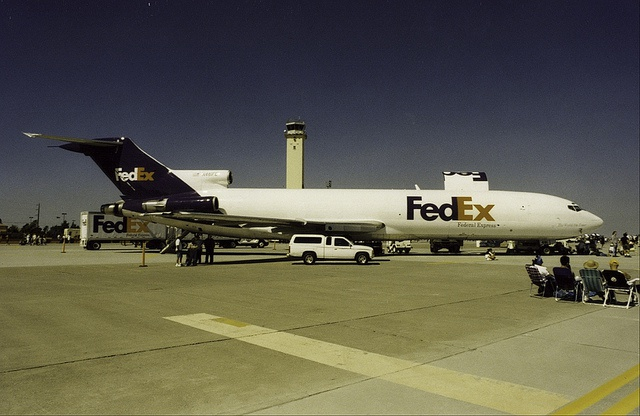Describe the objects in this image and their specific colors. I can see airplane in black, beige, and darkgreen tones, truck in black, gray, and darkgreen tones, truck in black, beige, and tan tones, chair in black, gray, and darkgreen tones, and chair in black, gray, and darkgreen tones in this image. 